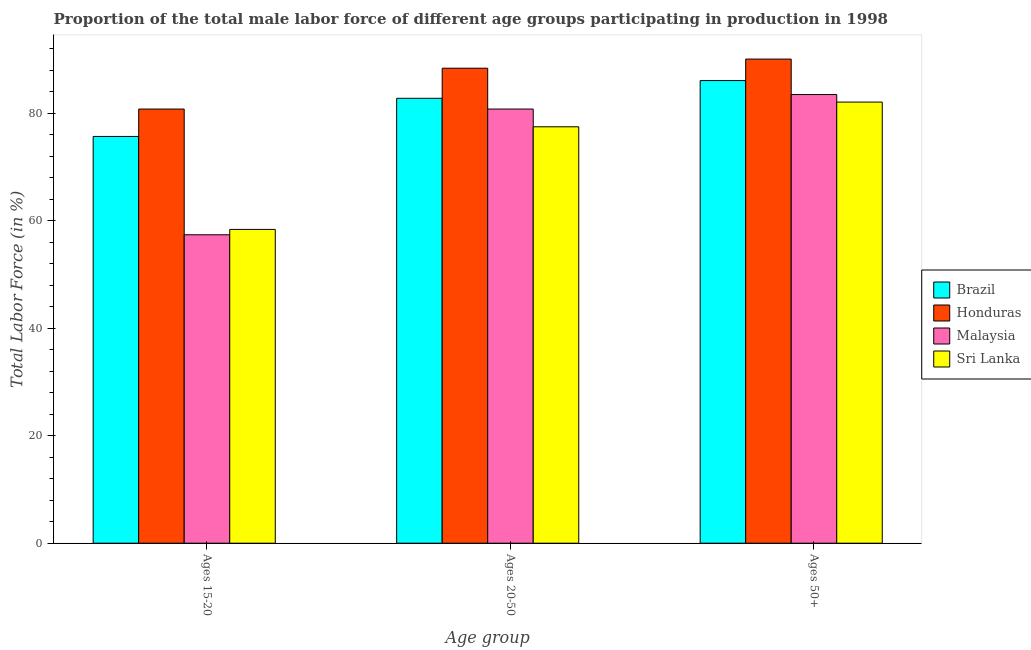How many different coloured bars are there?
Provide a short and direct response. 4. Are the number of bars per tick equal to the number of legend labels?
Your answer should be very brief. Yes. Are the number of bars on each tick of the X-axis equal?
Provide a short and direct response. Yes. How many bars are there on the 3rd tick from the left?
Your answer should be compact. 4. What is the label of the 3rd group of bars from the left?
Provide a succinct answer. Ages 50+. What is the percentage of male labor force within the age group 20-50 in Brazil?
Give a very brief answer. 82.8. Across all countries, what is the maximum percentage of male labor force above age 50?
Give a very brief answer. 90.1. Across all countries, what is the minimum percentage of male labor force within the age group 15-20?
Your response must be concise. 57.4. In which country was the percentage of male labor force above age 50 maximum?
Keep it short and to the point. Honduras. In which country was the percentage of male labor force within the age group 20-50 minimum?
Your response must be concise. Sri Lanka. What is the total percentage of male labor force above age 50 in the graph?
Make the answer very short. 341.8. What is the difference between the percentage of male labor force above age 50 in Sri Lanka and that in Malaysia?
Offer a very short reply. -1.4. What is the average percentage of male labor force within the age group 20-50 per country?
Keep it short and to the point. 82.38. What is the difference between the percentage of male labor force within the age group 15-20 and percentage of male labor force above age 50 in Honduras?
Your response must be concise. -9.3. In how many countries, is the percentage of male labor force within the age group 15-20 greater than 64 %?
Give a very brief answer. 2. What is the ratio of the percentage of male labor force within the age group 20-50 in Brazil to that in Honduras?
Your answer should be compact. 0.94. Is the difference between the percentage of male labor force within the age group 20-50 in Sri Lanka and Malaysia greater than the difference between the percentage of male labor force above age 50 in Sri Lanka and Malaysia?
Your answer should be compact. No. What is the difference between the highest and the second highest percentage of male labor force within the age group 15-20?
Give a very brief answer. 5.1. What is the difference between the highest and the lowest percentage of male labor force above age 50?
Provide a succinct answer. 8. Is the sum of the percentage of male labor force within the age group 20-50 in Honduras and Malaysia greater than the maximum percentage of male labor force within the age group 15-20 across all countries?
Provide a short and direct response. Yes. What does the 3rd bar from the left in Ages 15-20 represents?
Your response must be concise. Malaysia. What does the 3rd bar from the right in Ages 20-50 represents?
Make the answer very short. Honduras. Is it the case that in every country, the sum of the percentage of male labor force within the age group 15-20 and percentage of male labor force within the age group 20-50 is greater than the percentage of male labor force above age 50?
Your answer should be very brief. Yes. How many bars are there?
Your response must be concise. 12. What is the difference between two consecutive major ticks on the Y-axis?
Your answer should be very brief. 20. Are the values on the major ticks of Y-axis written in scientific E-notation?
Ensure brevity in your answer.  No. Does the graph contain any zero values?
Ensure brevity in your answer.  No. Does the graph contain grids?
Your answer should be very brief. No. Where does the legend appear in the graph?
Ensure brevity in your answer.  Center right. What is the title of the graph?
Ensure brevity in your answer.  Proportion of the total male labor force of different age groups participating in production in 1998. Does "Eritrea" appear as one of the legend labels in the graph?
Provide a succinct answer. No. What is the label or title of the X-axis?
Provide a succinct answer. Age group. What is the Total Labor Force (in %) of Brazil in Ages 15-20?
Offer a very short reply. 75.7. What is the Total Labor Force (in %) of Honduras in Ages 15-20?
Provide a short and direct response. 80.8. What is the Total Labor Force (in %) in Malaysia in Ages 15-20?
Offer a very short reply. 57.4. What is the Total Labor Force (in %) in Sri Lanka in Ages 15-20?
Offer a terse response. 58.4. What is the Total Labor Force (in %) of Brazil in Ages 20-50?
Your answer should be compact. 82.8. What is the Total Labor Force (in %) of Honduras in Ages 20-50?
Keep it short and to the point. 88.4. What is the Total Labor Force (in %) of Malaysia in Ages 20-50?
Provide a short and direct response. 80.8. What is the Total Labor Force (in %) in Sri Lanka in Ages 20-50?
Offer a very short reply. 77.5. What is the Total Labor Force (in %) of Brazil in Ages 50+?
Keep it short and to the point. 86.1. What is the Total Labor Force (in %) in Honduras in Ages 50+?
Provide a succinct answer. 90.1. What is the Total Labor Force (in %) in Malaysia in Ages 50+?
Offer a very short reply. 83.5. What is the Total Labor Force (in %) of Sri Lanka in Ages 50+?
Provide a short and direct response. 82.1. Across all Age group, what is the maximum Total Labor Force (in %) in Brazil?
Keep it short and to the point. 86.1. Across all Age group, what is the maximum Total Labor Force (in %) in Honduras?
Your response must be concise. 90.1. Across all Age group, what is the maximum Total Labor Force (in %) in Malaysia?
Offer a terse response. 83.5. Across all Age group, what is the maximum Total Labor Force (in %) in Sri Lanka?
Your response must be concise. 82.1. Across all Age group, what is the minimum Total Labor Force (in %) of Brazil?
Provide a short and direct response. 75.7. Across all Age group, what is the minimum Total Labor Force (in %) in Honduras?
Keep it short and to the point. 80.8. Across all Age group, what is the minimum Total Labor Force (in %) of Malaysia?
Give a very brief answer. 57.4. Across all Age group, what is the minimum Total Labor Force (in %) in Sri Lanka?
Your response must be concise. 58.4. What is the total Total Labor Force (in %) in Brazil in the graph?
Keep it short and to the point. 244.6. What is the total Total Labor Force (in %) in Honduras in the graph?
Your answer should be compact. 259.3. What is the total Total Labor Force (in %) of Malaysia in the graph?
Make the answer very short. 221.7. What is the total Total Labor Force (in %) of Sri Lanka in the graph?
Give a very brief answer. 218. What is the difference between the Total Labor Force (in %) of Brazil in Ages 15-20 and that in Ages 20-50?
Make the answer very short. -7.1. What is the difference between the Total Labor Force (in %) in Malaysia in Ages 15-20 and that in Ages 20-50?
Provide a short and direct response. -23.4. What is the difference between the Total Labor Force (in %) of Sri Lanka in Ages 15-20 and that in Ages 20-50?
Offer a terse response. -19.1. What is the difference between the Total Labor Force (in %) in Brazil in Ages 15-20 and that in Ages 50+?
Offer a very short reply. -10.4. What is the difference between the Total Labor Force (in %) of Honduras in Ages 15-20 and that in Ages 50+?
Your answer should be compact. -9.3. What is the difference between the Total Labor Force (in %) of Malaysia in Ages 15-20 and that in Ages 50+?
Ensure brevity in your answer.  -26.1. What is the difference between the Total Labor Force (in %) in Sri Lanka in Ages 15-20 and that in Ages 50+?
Your answer should be very brief. -23.7. What is the difference between the Total Labor Force (in %) of Brazil in Ages 20-50 and that in Ages 50+?
Make the answer very short. -3.3. What is the difference between the Total Labor Force (in %) of Honduras in Ages 20-50 and that in Ages 50+?
Your response must be concise. -1.7. What is the difference between the Total Labor Force (in %) in Malaysia in Ages 20-50 and that in Ages 50+?
Provide a succinct answer. -2.7. What is the difference between the Total Labor Force (in %) in Sri Lanka in Ages 20-50 and that in Ages 50+?
Your answer should be very brief. -4.6. What is the difference between the Total Labor Force (in %) of Brazil in Ages 15-20 and the Total Labor Force (in %) of Honduras in Ages 20-50?
Your response must be concise. -12.7. What is the difference between the Total Labor Force (in %) in Brazil in Ages 15-20 and the Total Labor Force (in %) in Malaysia in Ages 20-50?
Give a very brief answer. -5.1. What is the difference between the Total Labor Force (in %) in Brazil in Ages 15-20 and the Total Labor Force (in %) in Sri Lanka in Ages 20-50?
Offer a very short reply. -1.8. What is the difference between the Total Labor Force (in %) of Honduras in Ages 15-20 and the Total Labor Force (in %) of Malaysia in Ages 20-50?
Give a very brief answer. 0. What is the difference between the Total Labor Force (in %) in Honduras in Ages 15-20 and the Total Labor Force (in %) in Sri Lanka in Ages 20-50?
Give a very brief answer. 3.3. What is the difference between the Total Labor Force (in %) of Malaysia in Ages 15-20 and the Total Labor Force (in %) of Sri Lanka in Ages 20-50?
Make the answer very short. -20.1. What is the difference between the Total Labor Force (in %) in Brazil in Ages 15-20 and the Total Labor Force (in %) in Honduras in Ages 50+?
Offer a terse response. -14.4. What is the difference between the Total Labor Force (in %) of Brazil in Ages 15-20 and the Total Labor Force (in %) of Sri Lanka in Ages 50+?
Ensure brevity in your answer.  -6.4. What is the difference between the Total Labor Force (in %) in Honduras in Ages 15-20 and the Total Labor Force (in %) in Malaysia in Ages 50+?
Provide a short and direct response. -2.7. What is the difference between the Total Labor Force (in %) of Honduras in Ages 15-20 and the Total Labor Force (in %) of Sri Lanka in Ages 50+?
Offer a terse response. -1.3. What is the difference between the Total Labor Force (in %) of Malaysia in Ages 15-20 and the Total Labor Force (in %) of Sri Lanka in Ages 50+?
Your answer should be very brief. -24.7. What is the difference between the Total Labor Force (in %) of Brazil in Ages 20-50 and the Total Labor Force (in %) of Malaysia in Ages 50+?
Provide a short and direct response. -0.7. What is the difference between the Total Labor Force (in %) in Brazil in Ages 20-50 and the Total Labor Force (in %) in Sri Lanka in Ages 50+?
Offer a very short reply. 0.7. What is the difference between the Total Labor Force (in %) of Honduras in Ages 20-50 and the Total Labor Force (in %) of Sri Lanka in Ages 50+?
Your answer should be very brief. 6.3. What is the average Total Labor Force (in %) of Brazil per Age group?
Provide a succinct answer. 81.53. What is the average Total Labor Force (in %) in Honduras per Age group?
Offer a terse response. 86.43. What is the average Total Labor Force (in %) of Malaysia per Age group?
Provide a succinct answer. 73.9. What is the average Total Labor Force (in %) in Sri Lanka per Age group?
Provide a short and direct response. 72.67. What is the difference between the Total Labor Force (in %) in Brazil and Total Labor Force (in %) in Malaysia in Ages 15-20?
Provide a succinct answer. 18.3. What is the difference between the Total Labor Force (in %) in Honduras and Total Labor Force (in %) in Malaysia in Ages 15-20?
Offer a very short reply. 23.4. What is the difference between the Total Labor Force (in %) in Honduras and Total Labor Force (in %) in Sri Lanka in Ages 15-20?
Offer a very short reply. 22.4. What is the difference between the Total Labor Force (in %) of Brazil and Total Labor Force (in %) of Honduras in Ages 20-50?
Provide a short and direct response. -5.6. What is the difference between the Total Labor Force (in %) of Brazil and Total Labor Force (in %) of Malaysia in Ages 20-50?
Offer a very short reply. 2. What is the difference between the Total Labor Force (in %) in Brazil and Total Labor Force (in %) in Sri Lanka in Ages 20-50?
Offer a very short reply. 5.3. What is the difference between the Total Labor Force (in %) in Brazil and Total Labor Force (in %) in Sri Lanka in Ages 50+?
Provide a short and direct response. 4. What is the difference between the Total Labor Force (in %) of Honduras and Total Labor Force (in %) of Sri Lanka in Ages 50+?
Give a very brief answer. 8. What is the difference between the Total Labor Force (in %) in Malaysia and Total Labor Force (in %) in Sri Lanka in Ages 50+?
Keep it short and to the point. 1.4. What is the ratio of the Total Labor Force (in %) of Brazil in Ages 15-20 to that in Ages 20-50?
Offer a very short reply. 0.91. What is the ratio of the Total Labor Force (in %) of Honduras in Ages 15-20 to that in Ages 20-50?
Offer a terse response. 0.91. What is the ratio of the Total Labor Force (in %) of Malaysia in Ages 15-20 to that in Ages 20-50?
Provide a short and direct response. 0.71. What is the ratio of the Total Labor Force (in %) of Sri Lanka in Ages 15-20 to that in Ages 20-50?
Provide a succinct answer. 0.75. What is the ratio of the Total Labor Force (in %) in Brazil in Ages 15-20 to that in Ages 50+?
Your answer should be very brief. 0.88. What is the ratio of the Total Labor Force (in %) of Honduras in Ages 15-20 to that in Ages 50+?
Give a very brief answer. 0.9. What is the ratio of the Total Labor Force (in %) in Malaysia in Ages 15-20 to that in Ages 50+?
Your answer should be very brief. 0.69. What is the ratio of the Total Labor Force (in %) of Sri Lanka in Ages 15-20 to that in Ages 50+?
Your response must be concise. 0.71. What is the ratio of the Total Labor Force (in %) in Brazil in Ages 20-50 to that in Ages 50+?
Give a very brief answer. 0.96. What is the ratio of the Total Labor Force (in %) in Honduras in Ages 20-50 to that in Ages 50+?
Give a very brief answer. 0.98. What is the ratio of the Total Labor Force (in %) of Sri Lanka in Ages 20-50 to that in Ages 50+?
Offer a terse response. 0.94. What is the difference between the highest and the second highest Total Labor Force (in %) in Malaysia?
Your response must be concise. 2.7. What is the difference between the highest and the lowest Total Labor Force (in %) in Brazil?
Provide a short and direct response. 10.4. What is the difference between the highest and the lowest Total Labor Force (in %) of Malaysia?
Offer a terse response. 26.1. What is the difference between the highest and the lowest Total Labor Force (in %) in Sri Lanka?
Provide a succinct answer. 23.7. 